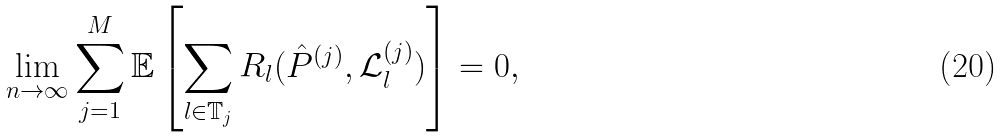Convert formula to latex. <formula><loc_0><loc_0><loc_500><loc_500>\lim _ { n \rightarrow \infty } \sum _ { j = 1 } ^ { M } \mathbb { E } \left [ \sum _ { l \in \mathbb { T } _ { j } } R _ { l } ( \hat { P } ^ { ( j ) } , \mathcal { L } _ { l } ^ { ( j ) } ) \right ] = 0 ,</formula> 